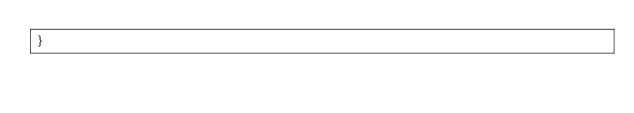<code> <loc_0><loc_0><loc_500><loc_500><_Awk_>}
</code> 